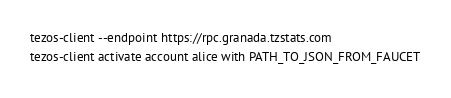Convert code to text. <code><loc_0><loc_0><loc_500><loc_500><_Bash_>tezos-client --endpoint https://rpc.granada.tzstats.com
tezos-client activate account alice with PATH_TO_JSON_FROM_FAUCET</code> 